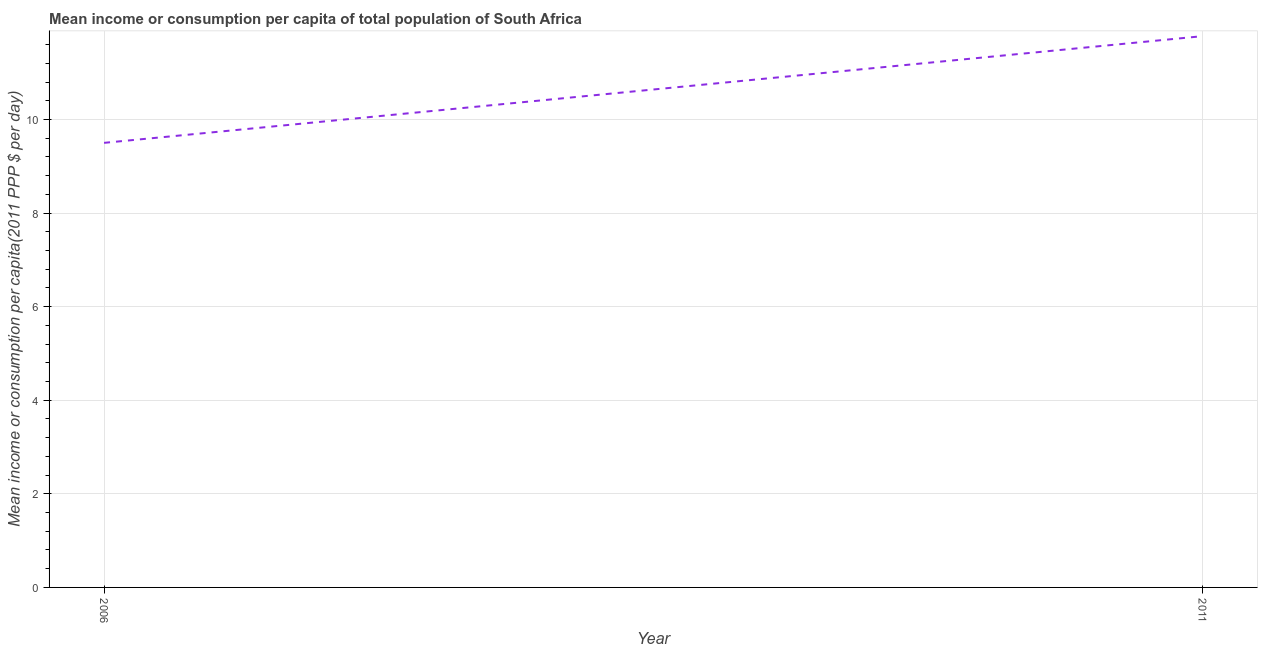What is the mean income or consumption in 2006?
Your response must be concise. 9.5. Across all years, what is the maximum mean income or consumption?
Make the answer very short. 11.78. What is the sum of the mean income or consumption?
Make the answer very short. 21.28. What is the difference between the mean income or consumption in 2006 and 2011?
Offer a terse response. -2.28. What is the average mean income or consumption per year?
Provide a short and direct response. 10.64. What is the median mean income or consumption?
Provide a short and direct response. 10.64. Do a majority of the years between 2006 and 2011 (inclusive) have mean income or consumption greater than 7.2 $?
Keep it short and to the point. Yes. What is the ratio of the mean income or consumption in 2006 to that in 2011?
Your answer should be very brief. 0.81. Is the mean income or consumption in 2006 less than that in 2011?
Your answer should be very brief. Yes. Does the mean income or consumption monotonically increase over the years?
Keep it short and to the point. Yes. How many lines are there?
Keep it short and to the point. 1. Are the values on the major ticks of Y-axis written in scientific E-notation?
Your answer should be compact. No. Does the graph contain any zero values?
Offer a very short reply. No. What is the title of the graph?
Provide a succinct answer. Mean income or consumption per capita of total population of South Africa. What is the label or title of the X-axis?
Your answer should be compact. Year. What is the label or title of the Y-axis?
Offer a very short reply. Mean income or consumption per capita(2011 PPP $ per day). What is the Mean income or consumption per capita(2011 PPP $ per day) of 2011?
Your answer should be very brief. 11.78. What is the difference between the Mean income or consumption per capita(2011 PPP $ per day) in 2006 and 2011?
Make the answer very short. -2.28. What is the ratio of the Mean income or consumption per capita(2011 PPP $ per day) in 2006 to that in 2011?
Give a very brief answer. 0.81. 